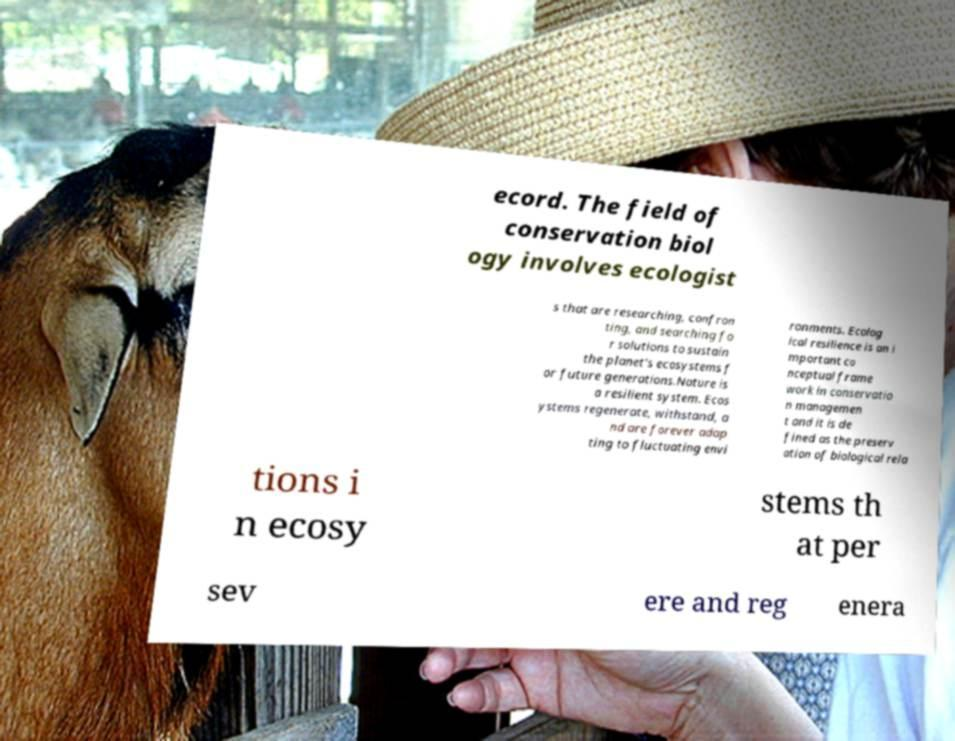What messages or text are displayed in this image? I need them in a readable, typed format. ecord. The field of conservation biol ogy involves ecologist s that are researching, confron ting, and searching fo r solutions to sustain the planet's ecosystems f or future generations.Nature is a resilient system. Ecos ystems regenerate, withstand, a nd are forever adap ting to fluctuating envi ronments. Ecolog ical resilience is an i mportant co nceptual frame work in conservatio n managemen t and it is de fined as the preserv ation of biological rela tions i n ecosy stems th at per sev ere and reg enera 